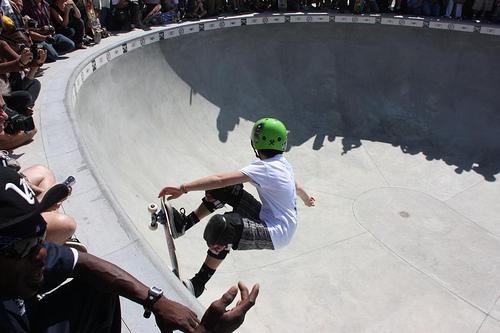Does the skateboarder have an audience?
Answer briefly. Yes. What color is the guy's helmet?
Short answer required. Green. What did the cement bowl used to be?
Short answer required. Pool. Is the male riding the skateboard wearing a shirt?
Keep it brief. Yes. 